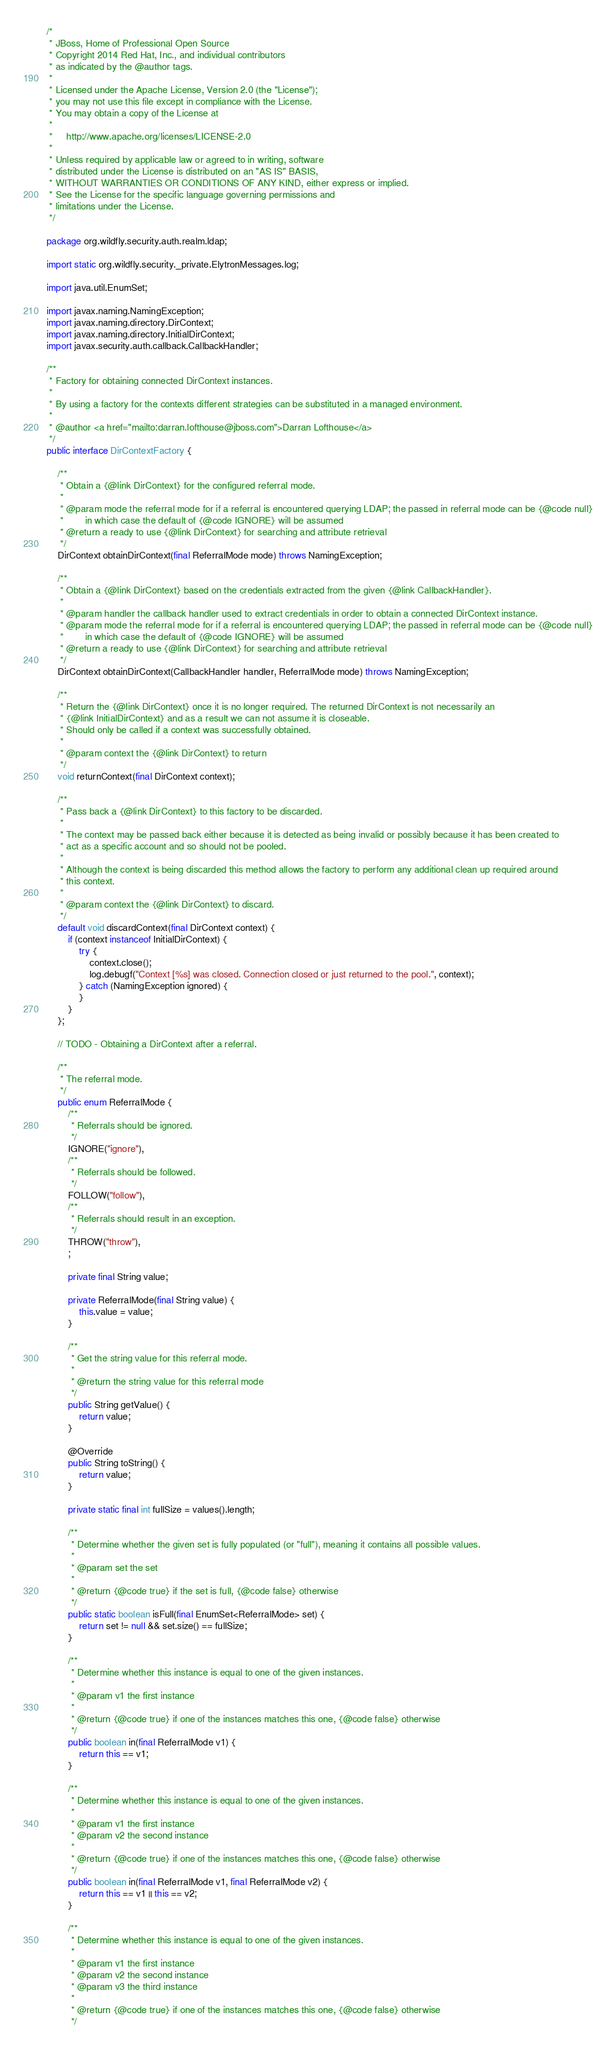Convert code to text. <code><loc_0><loc_0><loc_500><loc_500><_Java_>/*
 * JBoss, Home of Professional Open Source
 * Copyright 2014 Red Hat, Inc., and individual contributors
 * as indicated by the @author tags.
 *
 * Licensed under the Apache License, Version 2.0 (the "License");
 * you may not use this file except in compliance with the License.
 * You may obtain a copy of the License at
 *
 *     http://www.apache.org/licenses/LICENSE-2.0
 *
 * Unless required by applicable law or agreed to in writing, software
 * distributed under the License is distributed on an "AS IS" BASIS,
 * WITHOUT WARRANTIES OR CONDITIONS OF ANY KIND, either express or implied.
 * See the License for the specific language governing permissions and
 * limitations under the License.
 */

package org.wildfly.security.auth.realm.ldap;

import static org.wildfly.security._private.ElytronMessages.log;

import java.util.EnumSet;

import javax.naming.NamingException;
import javax.naming.directory.DirContext;
import javax.naming.directory.InitialDirContext;
import javax.security.auth.callback.CallbackHandler;

/**
 * Factory for obtaining connected DirContext instances.
 *
 * By using a factory for the contexts different strategies can be substituted in a managed environment.
 *
 * @author <a href="mailto:darran.lofthouse@jboss.com">Darran Lofthouse</a>
 */
public interface DirContextFactory {

    /**
     * Obtain a {@link DirContext} for the configured referral mode.
     *
     * @param mode the referral mode for if a referral is encountered querying LDAP; the passed in referral mode can be {@code null}
     *        in which case the default of {@code IGNORE} will be assumed
     * @return a ready to use {@link DirContext} for searching and attribute retrieval
     */
    DirContext obtainDirContext(final ReferralMode mode) throws NamingException;

    /**
     * Obtain a {@link DirContext} based on the credentials extracted from the given {@link CallbackHandler}.
     *
     * @param handler the callback handler used to extract credentials in order to obtain a connected DirContext instance.
     * @param mode the referral mode for if a referral is encountered querying LDAP; the passed in referral mode can be {@code null}
     *        in which case the default of {@code IGNORE} will be assumed
     * @return a ready to use {@link DirContext} for searching and attribute retrieval
     */
    DirContext obtainDirContext(CallbackHandler handler, ReferralMode mode) throws NamingException;

    /**
     * Return the {@link DirContext} once it is no longer required. The returned DirContext is not necessarily an
     * {@link InitialDirContext} and as a result we can not assume it is closeable.
     * Should only be called if a context was successfully obtained.
     *
     * @param context the {@link DirContext} to return
     */
    void returnContext(final DirContext context);

    /**
     * Pass back a {@link DirContext} to this factory to be discarded.
     *
     * The context may be passed back either because it is detected as being invalid or possibly because it has been created to
     * act as a specific account and so should not be pooled.
     *
     * Although the context is being discarded this method allows the factory to perform any additional clean up required around
     * this context.
     *
     * @param context the {@link DirContext} to discard.
     */
    default void discardContext(final DirContext context) {
        if (context instanceof InitialDirContext) {
            try {
                context.close();
                log.debugf("Context [%s] was closed. Connection closed or just returned to the pool.", context);
            } catch (NamingException ignored) {
            }
        }
    };

    // TODO - Obtaining a DirContext after a referral.

    /**
     * The referral mode.
     */
    public enum ReferralMode {
        /**
         * Referrals should be ignored.
         */
        IGNORE("ignore"),
        /**
         * Referrals should be followed.
         */
        FOLLOW("follow"),
        /**
         * Referrals should result in an exception.
         */
        THROW("throw"),
        ;

        private final String value;

        private ReferralMode(final String value) {
            this.value = value;
        }

        /**
         * Get the string value for this referral mode.
         *
         * @return the string value for this referral mode
         */
        public String getValue() {
            return value;
        }

        @Override
        public String toString() {
            return value;
        }

        private static final int fullSize = values().length;

        /**
         * Determine whether the given set is fully populated (or "full"), meaning it contains all possible values.
         *
         * @param set the set
         *
         * @return {@code true} if the set is full, {@code false} otherwise
         */
        public static boolean isFull(final EnumSet<ReferralMode> set) {
            return set != null && set.size() == fullSize;
        }

        /**
         * Determine whether this instance is equal to one of the given instances.
         *
         * @param v1 the first instance
         *
         * @return {@code true} if one of the instances matches this one, {@code false} otherwise
         */
        public boolean in(final ReferralMode v1) {
            return this == v1;
        }

        /**
         * Determine whether this instance is equal to one of the given instances.
         *
         * @param v1 the first instance
         * @param v2 the second instance
         *
         * @return {@code true} if one of the instances matches this one, {@code false} otherwise
         */
        public boolean in(final ReferralMode v1, final ReferralMode v2) {
            return this == v1 || this == v2;
        }

        /**
         * Determine whether this instance is equal to one of the given instances.
         *
         * @param v1 the first instance
         * @param v2 the second instance
         * @param v3 the third instance
         *
         * @return {@code true} if one of the instances matches this one, {@code false} otherwise
         */</code> 